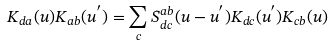<formula> <loc_0><loc_0><loc_500><loc_500>K _ { d a } ( u ) K _ { a b } ( u ^ { ^ { \prime } } ) = \sum _ { c } S _ { d c } ^ { a b } ( u - u ^ { ^ { \prime } } ) K _ { d c } ( u ^ { ^ { \prime } } ) K _ { c b } ( u )</formula> 